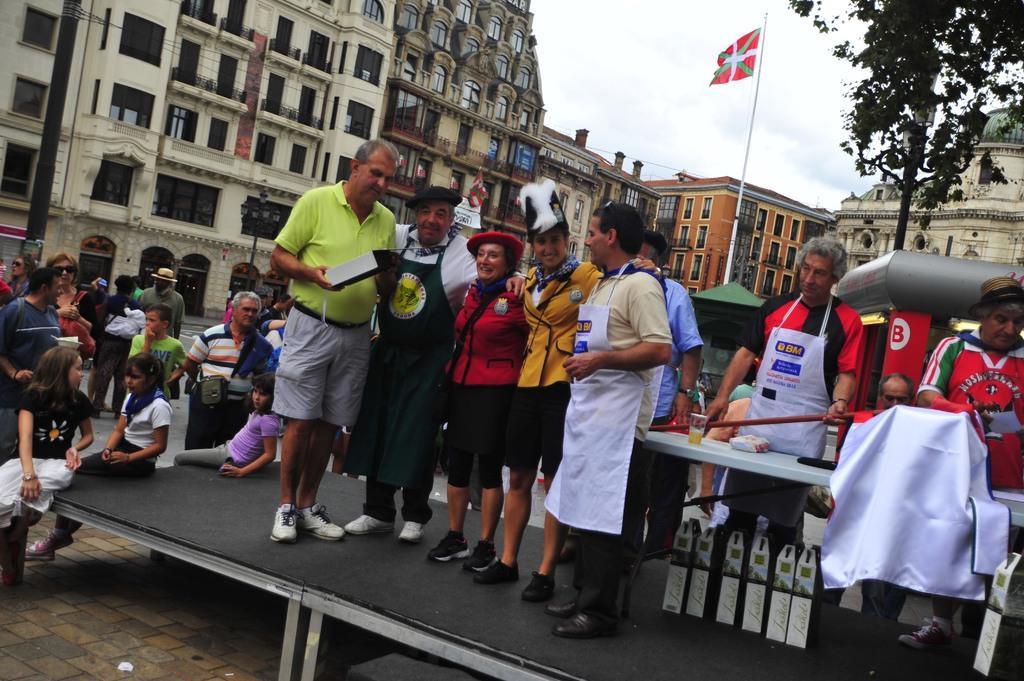Can you describe this image briefly? In this image we can see some people standing on the stage and we can also see buildings, flag, vehicles and tree. 